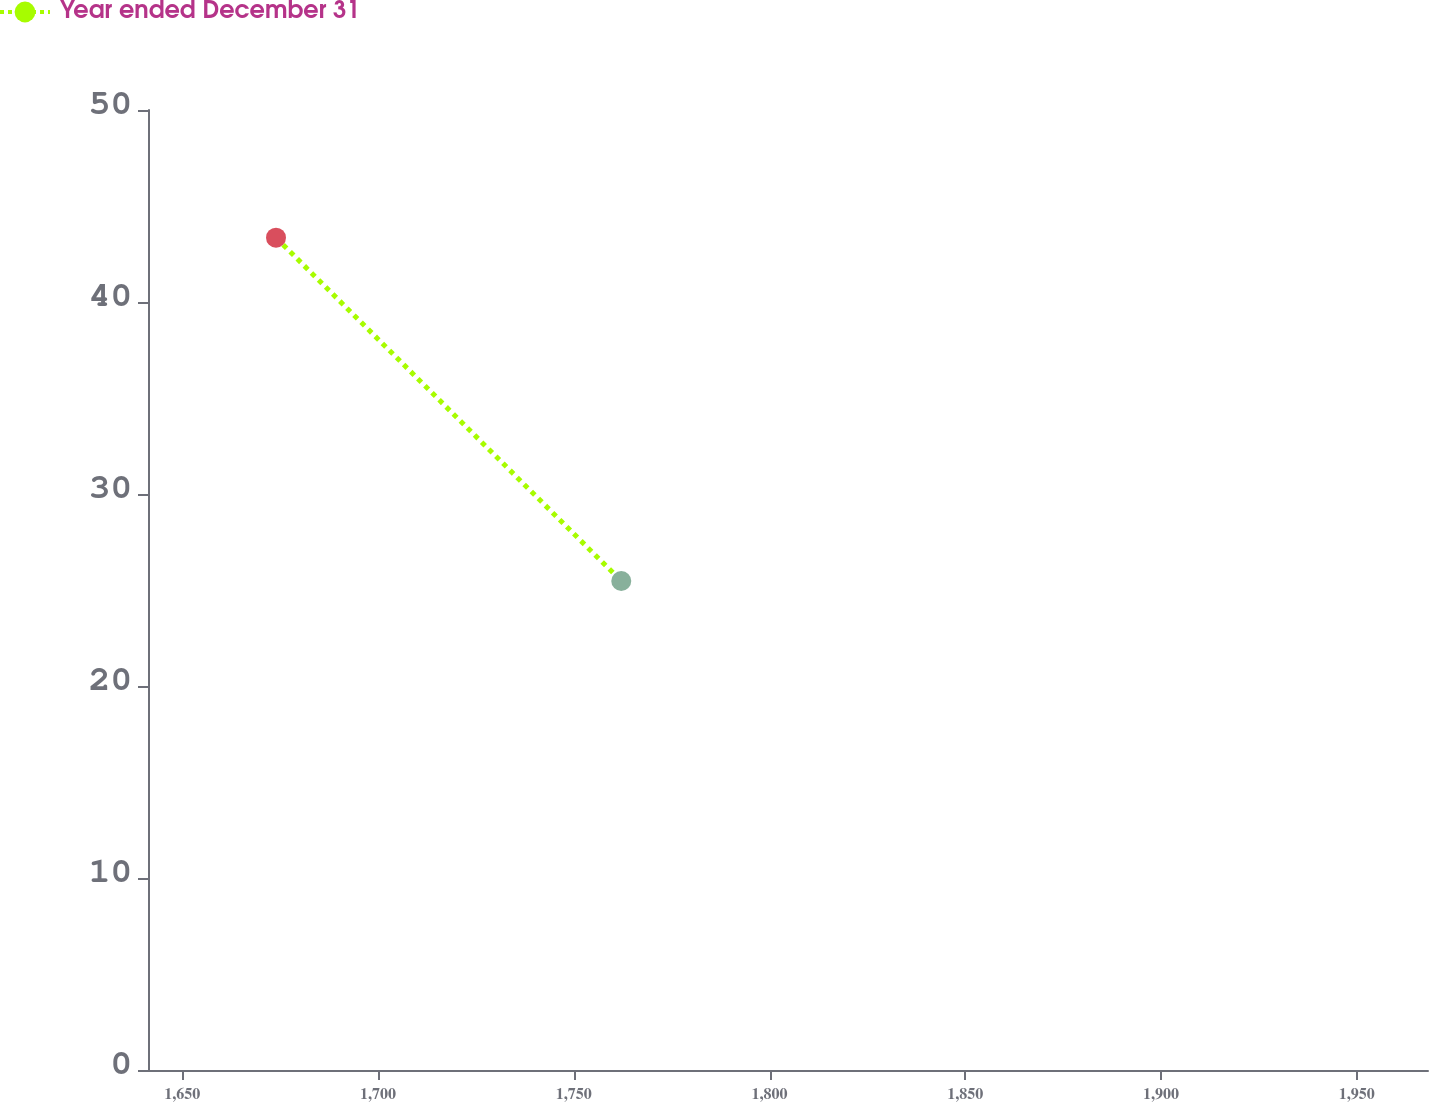<chart> <loc_0><loc_0><loc_500><loc_500><line_chart><ecel><fcel>Year ended December 31<nl><fcel>1673.96<fcel>43.35<nl><fcel>1762.14<fcel>25.47<nl><fcel>2000.86<fcel>21.53<nl></chart> 